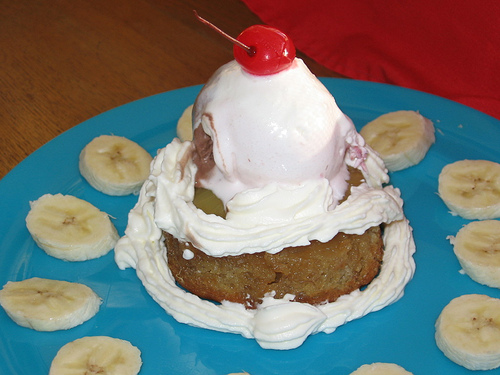<image>
Can you confirm if the cherry is to the left of the banana? Yes. From this viewpoint, the cherry is positioned to the left side relative to the banana. 